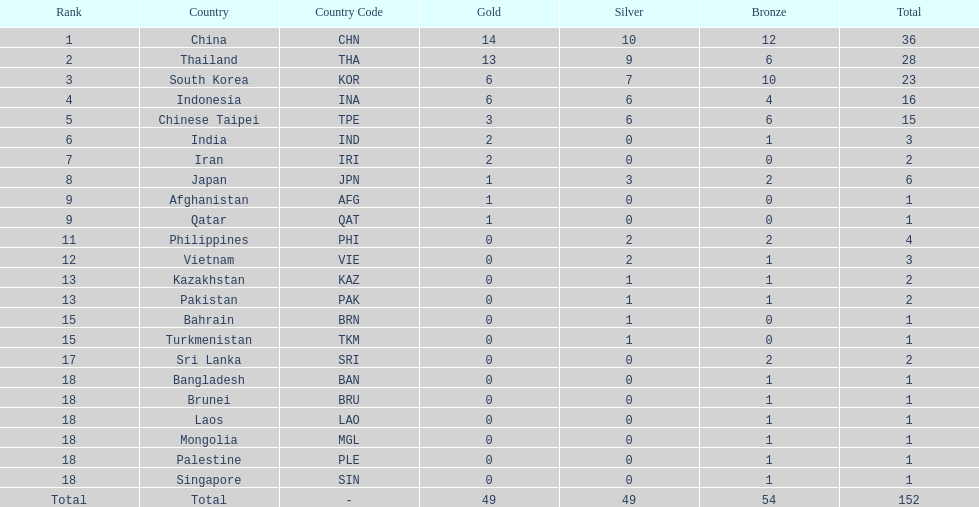Can you parse all the data within this table? {'header': ['Rank', 'Country', 'Country Code', 'Gold', 'Silver', 'Bronze', 'Total'], 'rows': [['1', 'China', 'CHN', '14', '10', '12', '36'], ['2', 'Thailand', 'THA', '13', '9', '6', '28'], ['3', 'South Korea', 'KOR', '6', '7', '10', '23'], ['4', 'Indonesia', 'INA', '6', '6', '4', '16'], ['5', 'Chinese Taipei', 'TPE', '3', '6', '6', '15'], ['6', 'India', 'IND', '2', '0', '1', '3'], ['7', 'Iran', 'IRI', '2', '0', '0', '2'], ['8', 'Japan', 'JPN', '1', '3', '2', '6'], ['9', 'Afghanistan', 'AFG', '1', '0', '0', '1'], ['9', 'Qatar', 'QAT', '1', '0', '0', '1'], ['11', 'Philippines', 'PHI', '0', '2', '2', '4'], ['12', 'Vietnam', 'VIE', '0', '2', '1', '3'], ['13', 'Kazakhstan', 'KAZ', '0', '1', '1', '2'], ['13', 'Pakistan', 'PAK', '0', '1', '1', '2'], ['15', 'Bahrain', 'BRN', '0', '1', '0', '1'], ['15', 'Turkmenistan', 'TKM', '0', '1', '0', '1'], ['17', 'Sri Lanka', 'SRI', '0', '0', '2', '2'], ['18', 'Bangladesh', 'BAN', '0', '0', '1', '1'], ['18', 'Brunei', 'BRU', '0', '0', '1', '1'], ['18', 'Laos', 'LAO', '0', '0', '1', '1'], ['18', 'Mongolia', 'MGL', '0', '0', '1', '1'], ['18', 'Palestine', 'PLE', '0', '0', '1', '1'], ['18', 'Singapore', 'SIN', '0', '0', '1', '1'], ['Total', 'Total', '-', '49', '49', '54', '152']]} How many nations received more than 5 gold medals? 4. 